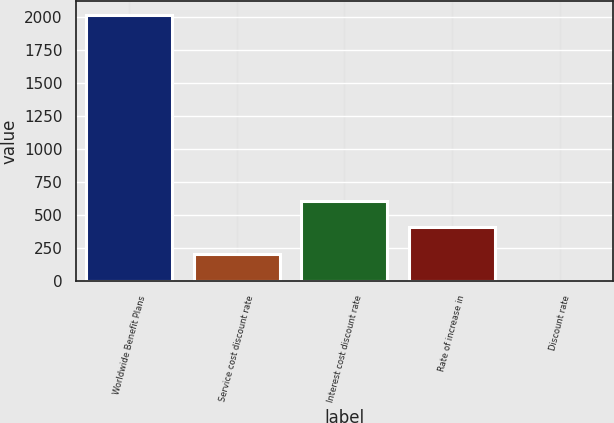Convert chart. <chart><loc_0><loc_0><loc_500><loc_500><bar_chart><fcel>Worldwide Benefit Plans<fcel>Service cost discount rate<fcel>Interest cost discount rate<fcel>Rate of increase in<fcel>Discount rate<nl><fcel>2016<fcel>205<fcel>607.44<fcel>406.22<fcel>3.78<nl></chart> 